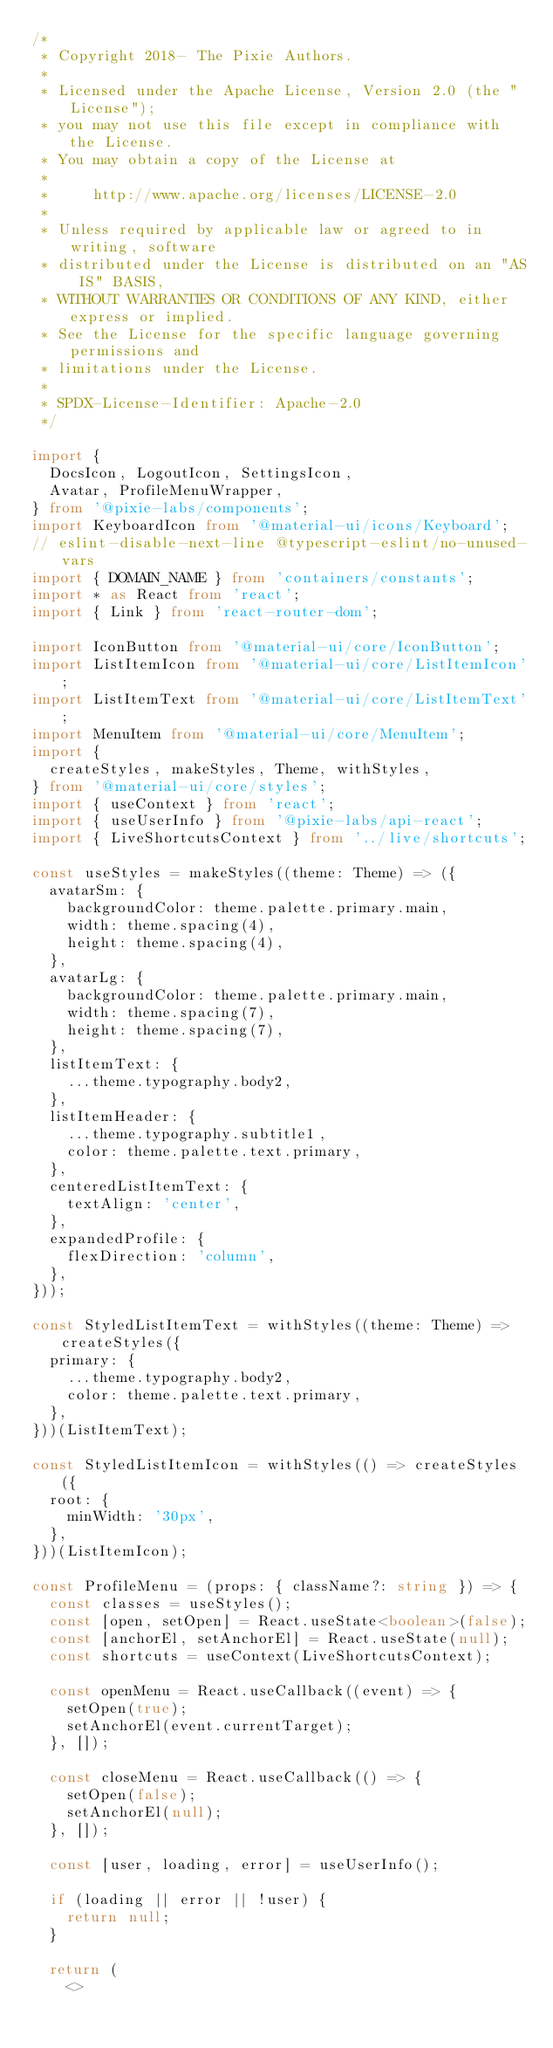Convert code to text. <code><loc_0><loc_0><loc_500><loc_500><_TypeScript_>/*
 * Copyright 2018- The Pixie Authors.
 *
 * Licensed under the Apache License, Version 2.0 (the "License");
 * you may not use this file except in compliance with the License.
 * You may obtain a copy of the License at
 *
 *     http://www.apache.org/licenses/LICENSE-2.0
 *
 * Unless required by applicable law or agreed to in writing, software
 * distributed under the License is distributed on an "AS IS" BASIS,
 * WITHOUT WARRANTIES OR CONDITIONS OF ANY KIND, either express or implied.
 * See the License for the specific language governing permissions and
 * limitations under the License.
 *
 * SPDX-License-Identifier: Apache-2.0
 */

import {
  DocsIcon, LogoutIcon, SettingsIcon,
  Avatar, ProfileMenuWrapper,
} from '@pixie-labs/components';
import KeyboardIcon from '@material-ui/icons/Keyboard';
// eslint-disable-next-line @typescript-eslint/no-unused-vars
import { DOMAIN_NAME } from 'containers/constants';
import * as React from 'react';
import { Link } from 'react-router-dom';

import IconButton from '@material-ui/core/IconButton';
import ListItemIcon from '@material-ui/core/ListItemIcon';
import ListItemText from '@material-ui/core/ListItemText';
import MenuItem from '@material-ui/core/MenuItem';
import {
  createStyles, makeStyles, Theme, withStyles,
} from '@material-ui/core/styles';
import { useContext } from 'react';
import { useUserInfo } from '@pixie-labs/api-react';
import { LiveShortcutsContext } from '../live/shortcuts';

const useStyles = makeStyles((theme: Theme) => ({
  avatarSm: {
    backgroundColor: theme.palette.primary.main,
    width: theme.spacing(4),
    height: theme.spacing(4),
  },
  avatarLg: {
    backgroundColor: theme.palette.primary.main,
    width: theme.spacing(7),
    height: theme.spacing(7),
  },
  listItemText: {
    ...theme.typography.body2,
  },
  listItemHeader: {
    ...theme.typography.subtitle1,
    color: theme.palette.text.primary,
  },
  centeredListItemText: {
    textAlign: 'center',
  },
  expandedProfile: {
    flexDirection: 'column',
  },
}));

const StyledListItemText = withStyles((theme: Theme) => createStyles({
  primary: {
    ...theme.typography.body2,
    color: theme.palette.text.primary,
  },
}))(ListItemText);

const StyledListItemIcon = withStyles(() => createStyles({
  root: {
    minWidth: '30px',
  },
}))(ListItemIcon);

const ProfileMenu = (props: { className?: string }) => {
  const classes = useStyles();
  const [open, setOpen] = React.useState<boolean>(false);
  const [anchorEl, setAnchorEl] = React.useState(null);
  const shortcuts = useContext(LiveShortcutsContext);

  const openMenu = React.useCallback((event) => {
    setOpen(true);
    setAnchorEl(event.currentTarget);
  }, []);

  const closeMenu = React.useCallback(() => {
    setOpen(false);
    setAnchorEl(null);
  }, []);

  const [user, loading, error] = useUserInfo();

  if (loading || error || !user) {
    return null;
  }

  return (
    <></code> 